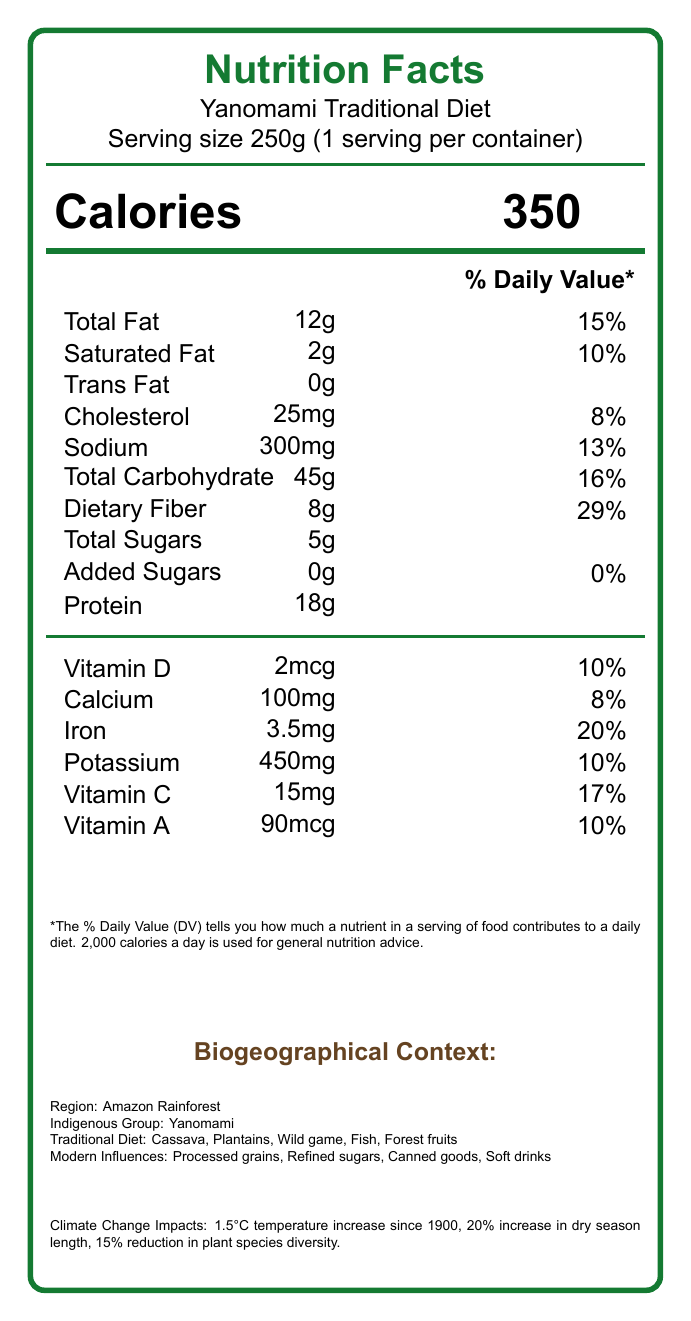What is the serving size of the Yanomami Traditional Diet as mentioned in the document? The document specifies that the serving size is 250g.
Answer: 250g How many calories are in one serving of the Yanomami Traditional Diet? The document lists the calorie content as 350 calories per serving.
Answer: 350 calories What are the traditional components of the Yanomami diet? The document mentions these as the traditional diet components.
Answer: Cassava, Plantains, Wild game, Fish, Forest fruits What is the percentage daily value of dietary fiber in the Yanomami Traditional Diet serving? The document indicates that the dietary fiber daily value is 29%.
Answer: 29% Which modern food influences are affecting the Yanomami diet? The document lists these as modern diet influences.
Answer: Processed grains, Refined sugars, Canned goods, Soft drinks How much potassium is in one serving of the Yanomami Traditional Diet? The document states that each serving contains 450mg of potassium.
Answer: 450mg What is the percentage daily value of saturated fat in one serving of the Yanomami Traditional Diet? A. 8% B. 10% C. 13% D. 15% The document notes that the saturated fat daily value is 10%.
Answer: B. 10% Which nutrient has the highest percentage daily value in one serving of the Yanomami Traditional Diet? A. Iron B. Vitamin D C. Calcium D. Potassium The document shows the daily value of iron as 20%, which is the highest among the listed nutrients.
Answer: A. Iron Is there any trans fat in the Yanomami Traditional Diet serving? The document indicates that the amount of trans fat is 0g.
Answer: No What are some traditional food preparation methods used by the Yanomami? The document mentions these methods as traditional food preparation techniques.
Answer: Fermentation, Sun-drying, Smoking, Roasting Summarize the main idea of the document. The document covers various aspects including nutritional facts, traditional and modern dietary components, climate change impacts, and significant shifts in dietary habits within the Yanomami community.
Answer: The document provides detailed nutritional information for a traditional Yanomami diet serving size of 250g, lists the biogeographical context and impacts of climate change on their diet, and notes how modern dietary influences are affecting their nutrition. What methods are used to analyze the ecological changes affecting the Yanomami's dietary sources? The document lists these GIS analysis methods.
Answer: Remote sensing of land cover changes, Species distribution modeling, Climate envelope modeling What is the temperature increase in the Amazon Rainforest since 1900? The document mentions a temperature increase of 1.5°C since 1900.
Answer: 1.5°C How long is the increased dry season length due to climate change? The document states there has been a 20% increase in the dry season length.
Answer: 20% increase What is the annual deforestation rate in the Amazon Rainforest as it affects the Yanomami? The document indicates a deforestation rate of 2% annually.
Answer: 2% Can the source of the datasets used for the GIS analysis be determined from the visual information? The document lists the datasets used in GIS analysis: WorldClim 2.1, MODIS Land Cover Product, Global Biodiversity Information Facility (GBIF).
Answer: Yes What are the impacts of the nutritional transition on the Yanomami community? The document details these effects of nutritional changes.
Answer: Increased obesity rates, increased diabetes prevalence, micronutrient deficiencies (Iron, Vitamin A, Zinc) 